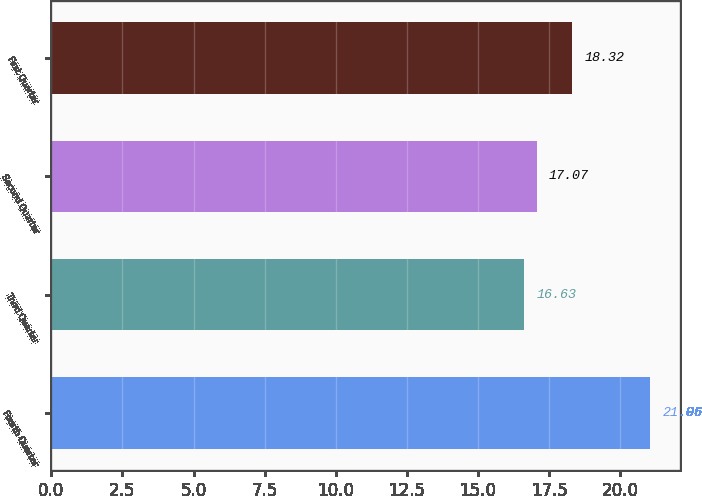Convert chart. <chart><loc_0><loc_0><loc_500><loc_500><bar_chart><fcel>Fourth Quarter<fcel>Third Quarter<fcel>Second Quarter<fcel>First Quarter<nl><fcel>21.06<fcel>16.63<fcel>17.07<fcel>18.32<nl></chart> 